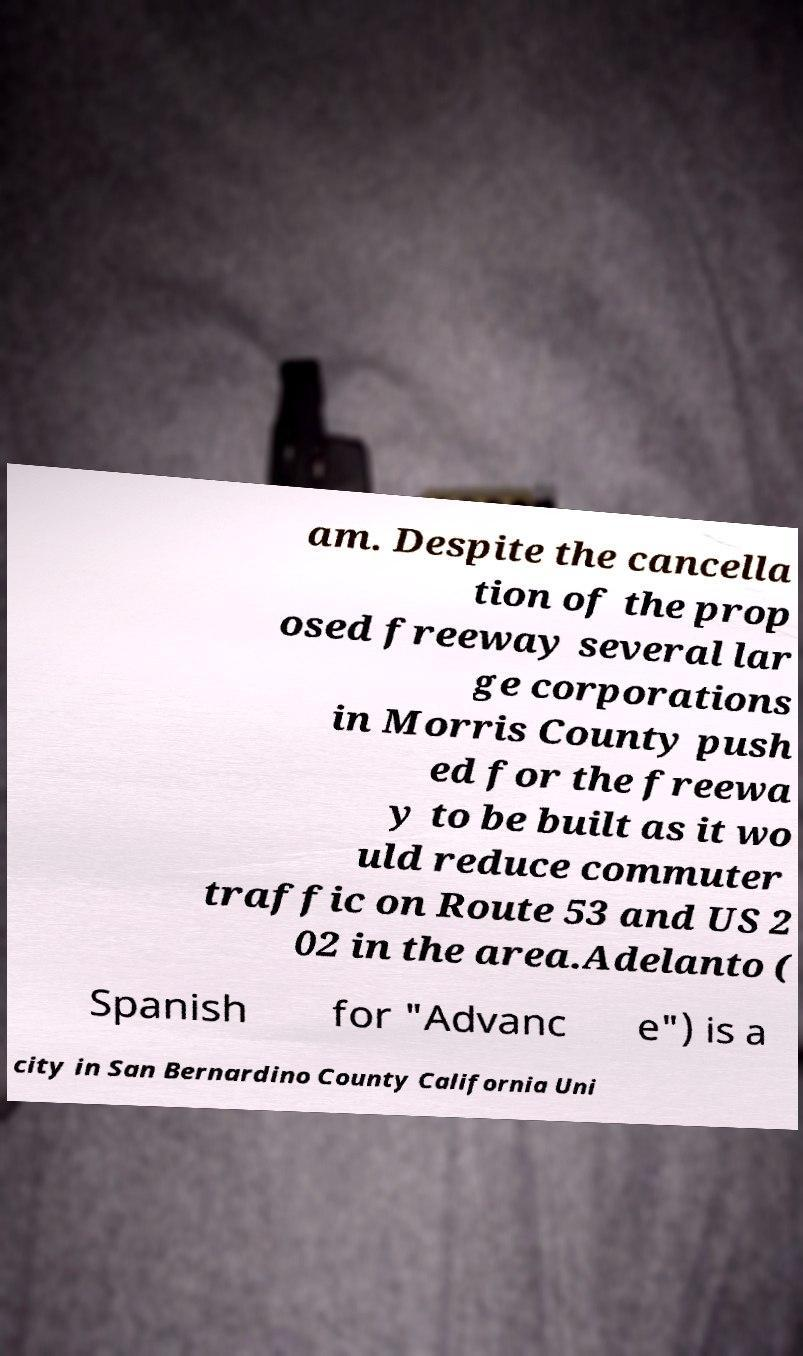Could you extract and type out the text from this image? am. Despite the cancella tion of the prop osed freeway several lar ge corporations in Morris County push ed for the freewa y to be built as it wo uld reduce commuter traffic on Route 53 and US 2 02 in the area.Adelanto ( Spanish for "Advanc e") is a city in San Bernardino County California Uni 